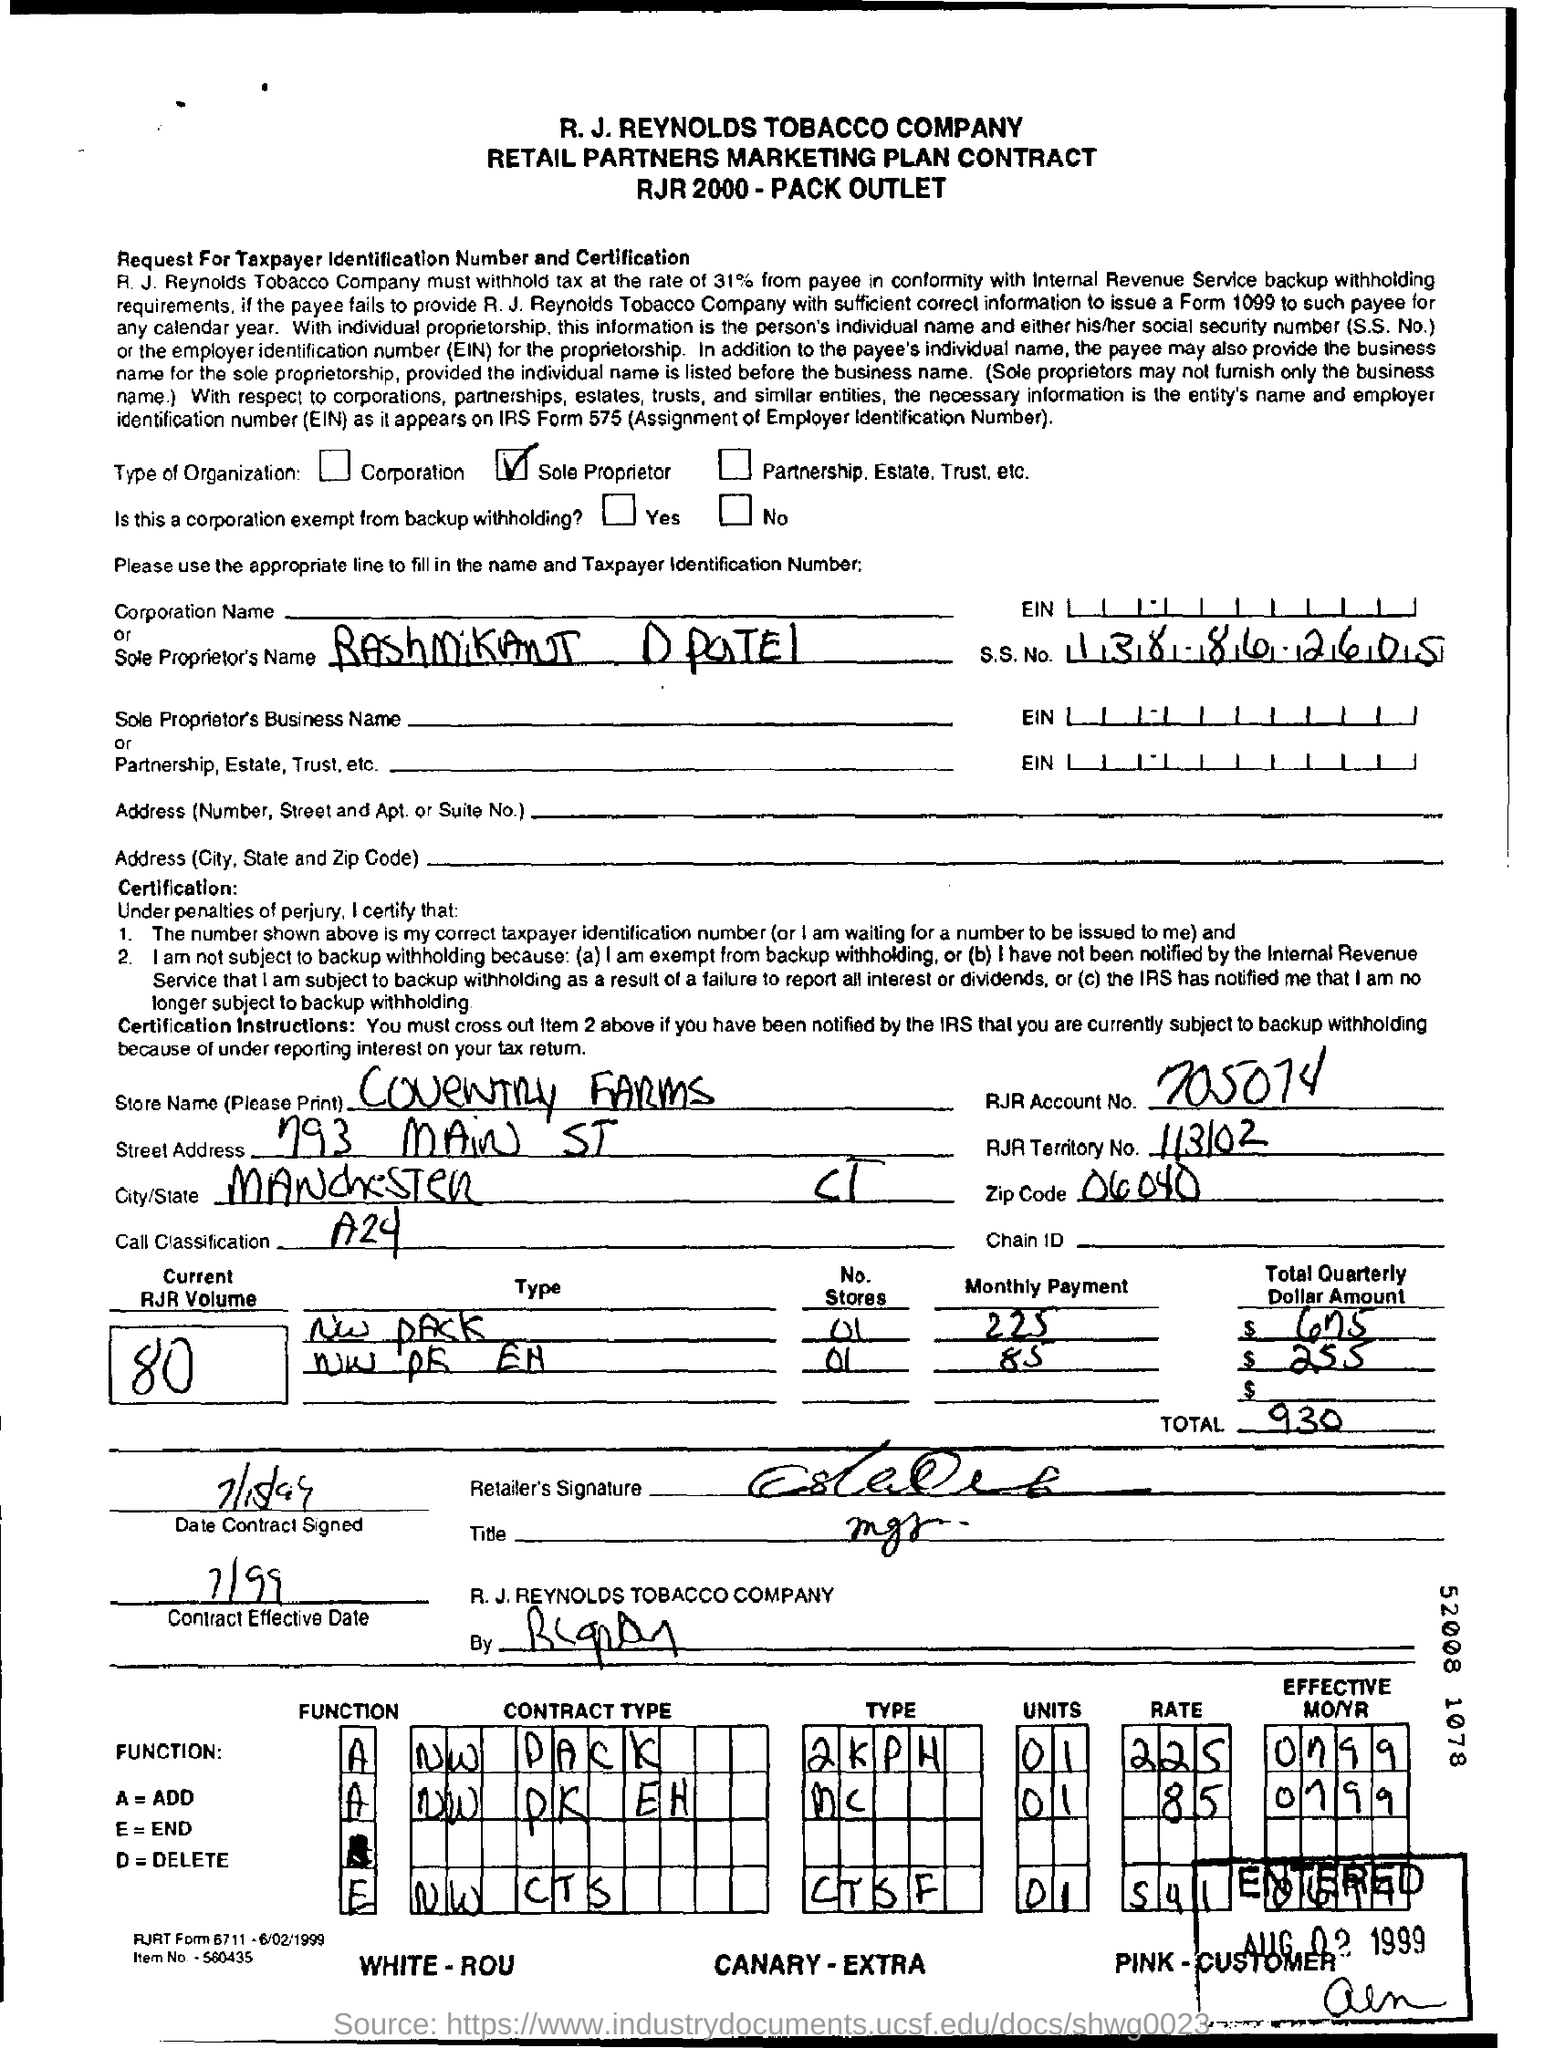What kind of document is shown in this image? This image displays a document which appears to be a Retail Partners Marketing Plan Contract associated with the R.J. Reynolds Tobacco Company for the year 2000. It appears to be for a 'Pack Outlet' agreement and includes sections for tax identification number, business details, and payment information.  Can you tell me about the date details found on the document? Certainly. The document includes a 'Date Contract Signed' section with a handwritten date, which appears to be '2/16', but the year isn't completely legible. Another date present is at the bottom, in a stamp or print, indicating 'AUG 02 1999', which may represent the date the form was last updated or printed. 